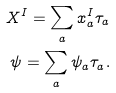Convert formula to latex. <formula><loc_0><loc_0><loc_500><loc_500>X ^ { I } = \sum _ { a } x ^ { I } _ { a } \tau _ { a } \\ \psi = \sum _ { a } \psi _ { a } \tau _ { a } .</formula> 